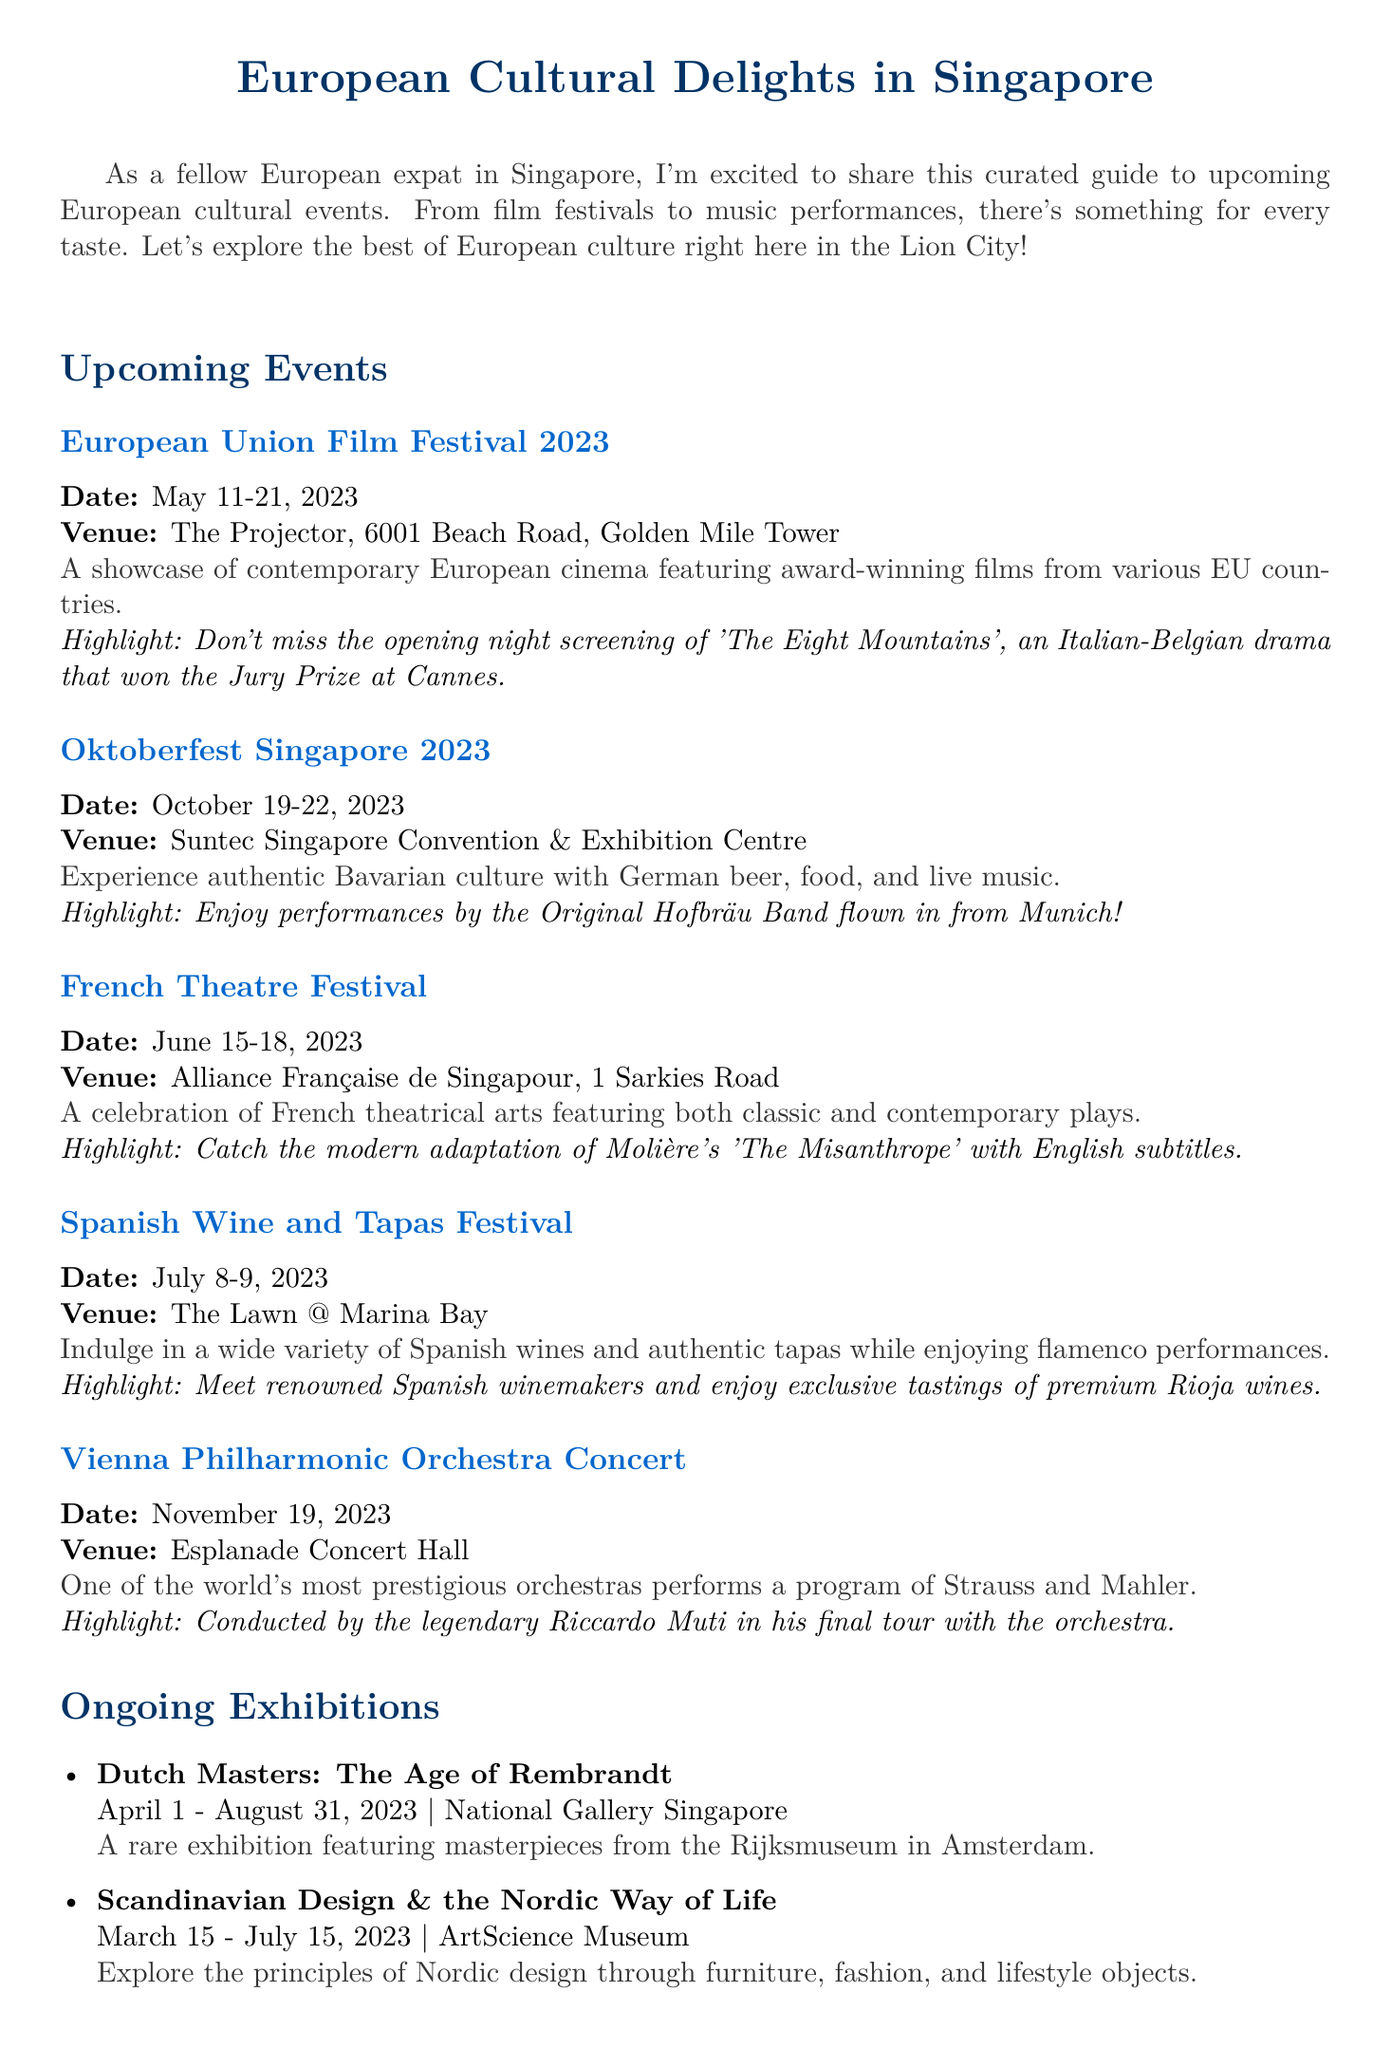What is the title of the newsletter? The title is stated at the beginning of the document, highlighting the main theme of the content.
Answer: European Cultural Delights in Singapore When does Oktoberfest Singapore 2023 take place? The dates of the event are provided in the event details, specifying when it will occur.
Answer: October 19-22, 2023 Where is the European Union Film Festival being held? The venue for this event is mentioned in the event details, indicating the location of the screening.
Answer: The Projector, 6001 Beach Road, Golden Mile Tower What is the highlight of the Vienna Philharmonic Orchestra Concert? The highlights section provides key details about notable features of the event, emphasizing its significance.
Answer: Conducted by the legendary Riccardo Muti in his final tour with the orchestra Which restaurant is highlighted in the European Dining Spotlight? The document specifically names the restaurant featured in this section.
Answer: Garibaldi Italian Restaurant & Bar What style of arts does the French Theatre Festival celebrate? The document describes the focus of this festival, detailing its artistic features.
Answer: French theatrical arts How long is the exhibition "Dutch Masters: The Age of Rembrandt" running? The duration of the exhibition is given in the ongoing exhibitions section, indicating its time frame.
Answer: April 1 - August 31, 2023 What is a recommended dish from Garibaldi Italian Restaurant? The document offers a specific recommendation from the restaurant, highlighting a culinary specialty.
Answer: Homemade tagliolini with fresh Sicilian red prawns and Amalfi lemon What type of event is the Spanish Wine and Tapas Festival? The description of the event explains its cultural and culinary focus.
Answer: Wine and tapas tasting 